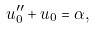Convert formula to latex. <formula><loc_0><loc_0><loc_500><loc_500>u _ { 0 } ^ { \prime \prime } + u _ { 0 } = \alpha ,</formula> 